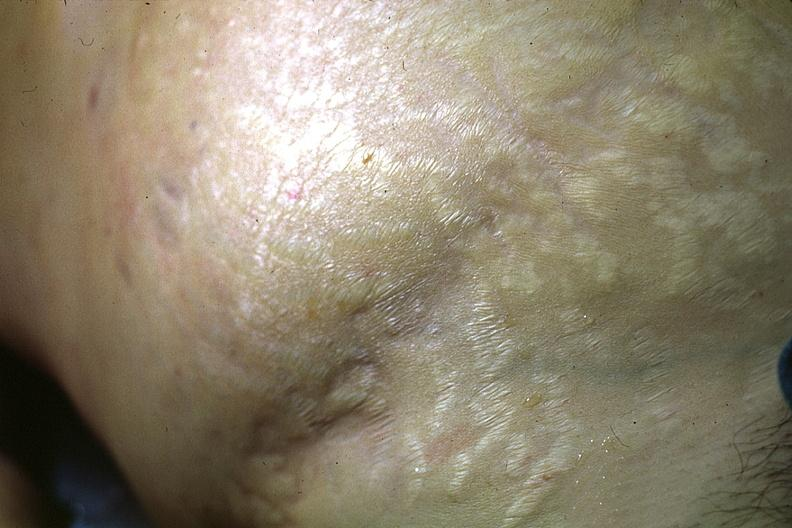does liver show good abdominal stria?
Answer the question using a single word or phrase. No 